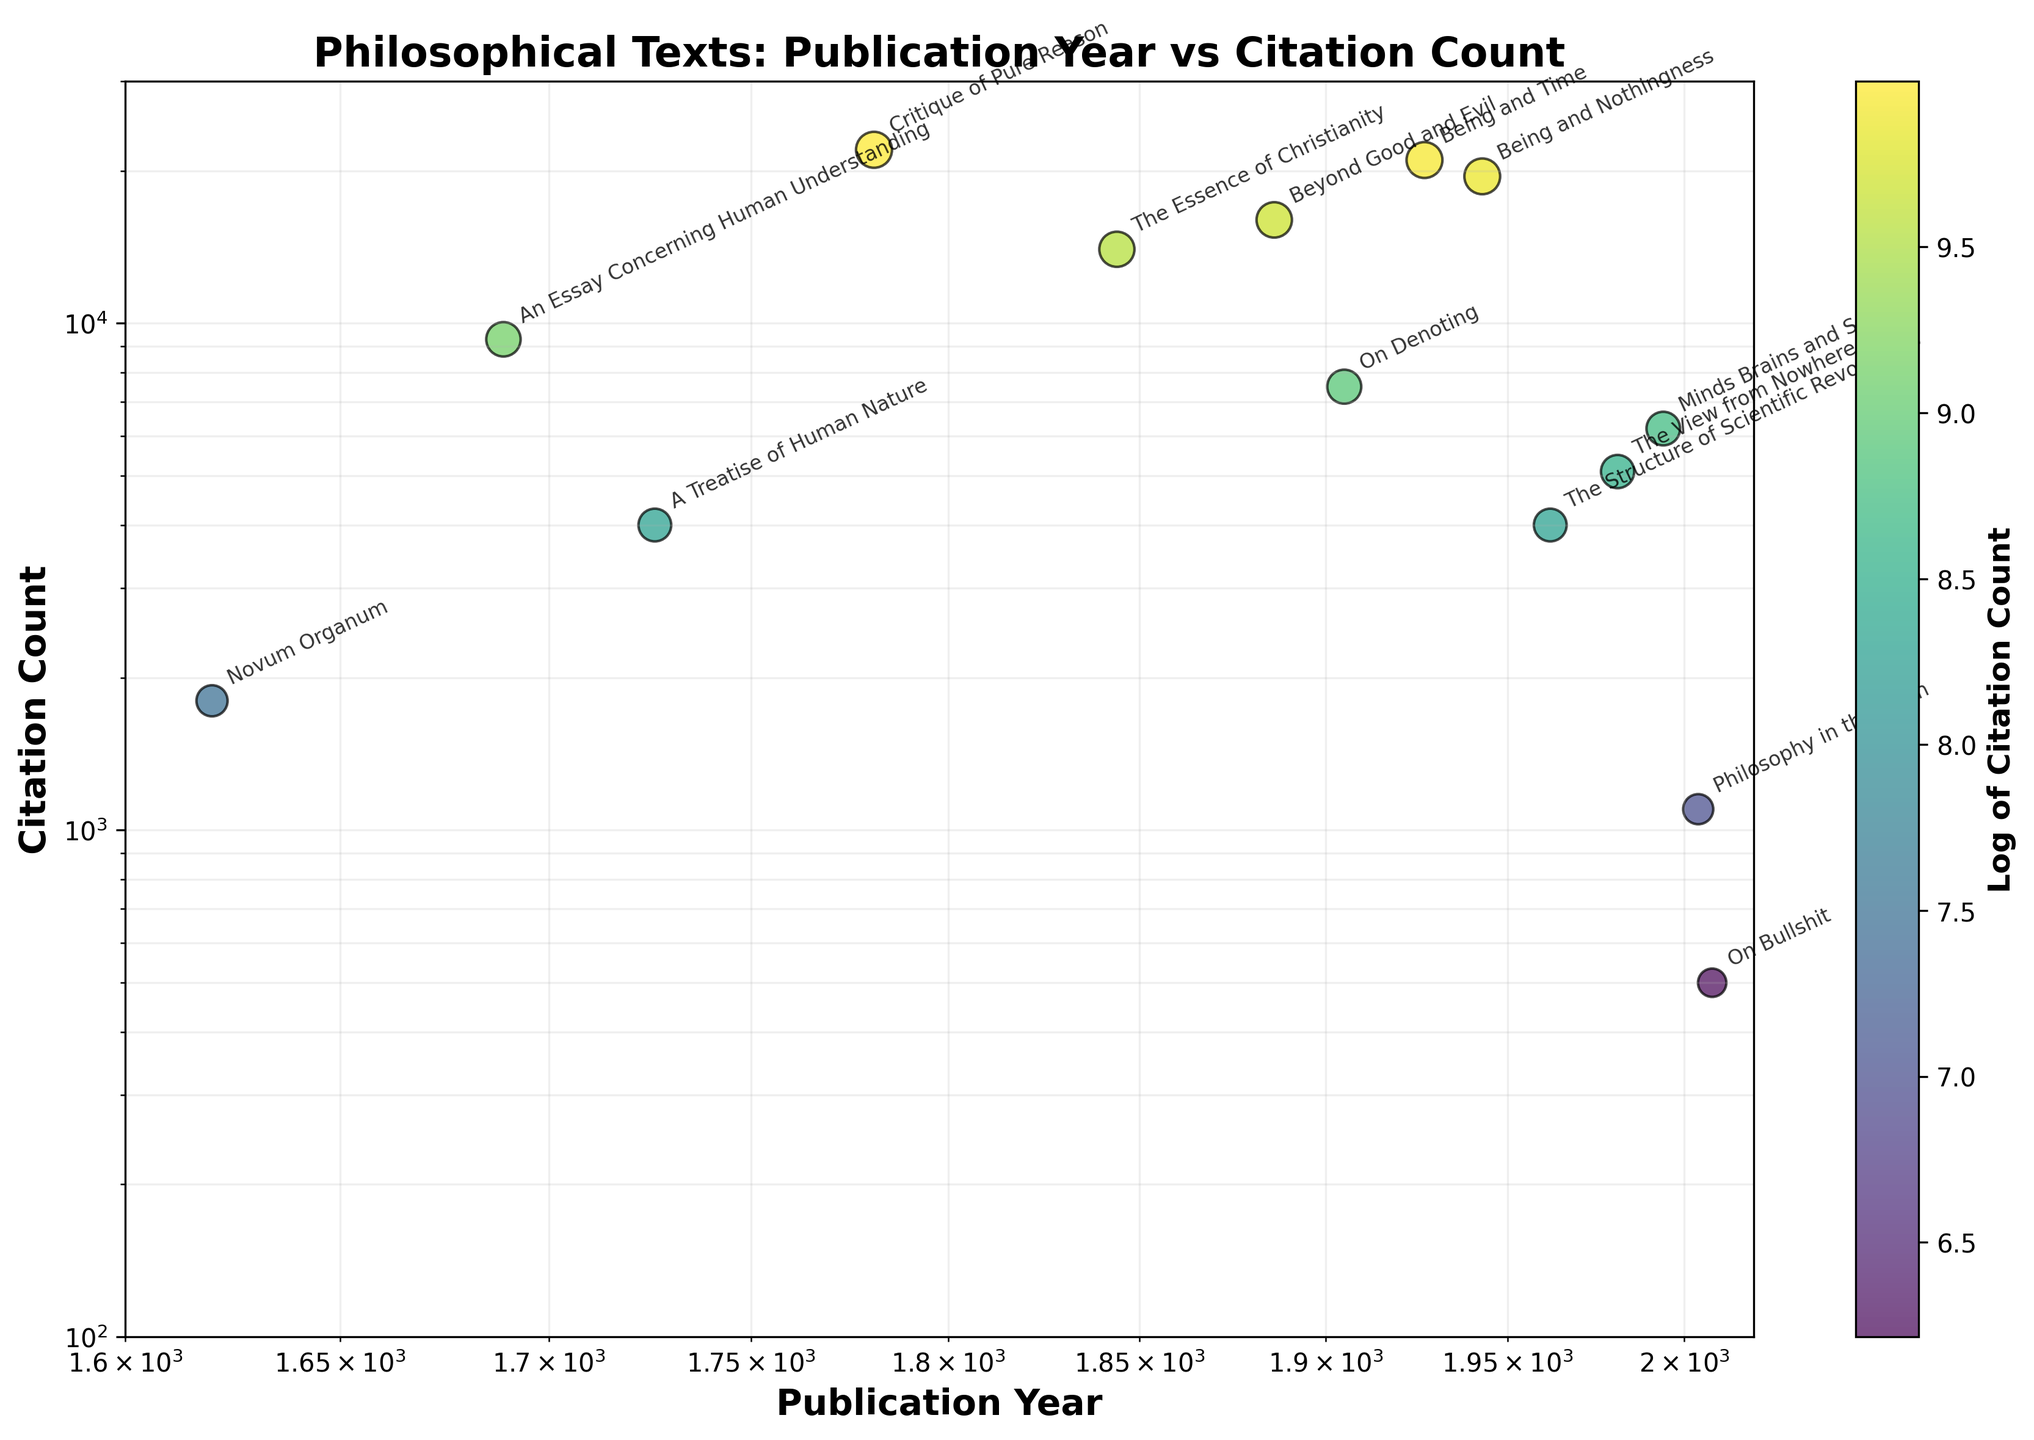What is the title of the plot? The title of the plot is displayed prominently above the graph, providing a summary of what the graph is about. In this case, the title specifies the relationship between philosophical texts, their publication year, and their citation counts.
Answer: Philosophical Texts: Publication Year vs Citation Count Which philosophical text has the highest citation count? To find the text with the highest citation count, look at the y-axis and identify the point that is positioned the highest. The annotations will help identify the corresponding text.
Answer: Critique of Pure Reason Are there more texts published before or after 1900? Count the number of data points on the left side (before 1900) and right side (after 1900) of the plot's x-axis. Compare these counts to determine which period has more published texts.
Answer: After 1900 Which author has two texts listed in the plot? Look for the annotations containing the names of texts and identify if any author's name appears more than once. In this plot, it is necessary to read the authors listed next to each text title.
Answer: Thomas Kuhn What does the color represent in the scatter plot? The plot has a color bar indicating that the color of each data point corresponds to the logarithm of the citation count. This means darker colors represent higher citation counts, while lighter colors represent lower ones.
Answer: Log of Citation Count How many texts have citation counts between 10,000 and 20,000? Examine the y-axis log scale and count the number of data points that fall within the range of 10,000 to 20,000. This involves identifying and counting the data points within this range.
Answer: 3 texts Which text has been published most recently? Examine the x-axis and identify the data point situated furthest to the right. The corresponding annotation will provide the title of the most recently published text.
Answer: On Bullshit How does the citation count of "A Treatise of Human Nature" compare with "The Essence of Christianity"? Determine the positions of these two texts on the y-axis. Compare the y-values (citation counts) directly to see which is higher.
Answer: The Essence of Christianity has a higher citation count than A Treatise of Human Nature What is the general trend observed between publication year and citation count? Look for a trend by observing the general direction of the data points. Despite the scatter, analyze if there is a visible correlation between the x-axis (publication year) and y-axis (citation count).
Answer: No strong visible trend What is the citation count for "Philosophy in the Flesh"? Locate the data point corresponding to "Philosophy in the Flesh" by finding its annotation and read off its y-axis value to determine the citation count.
Answer: 1,100 